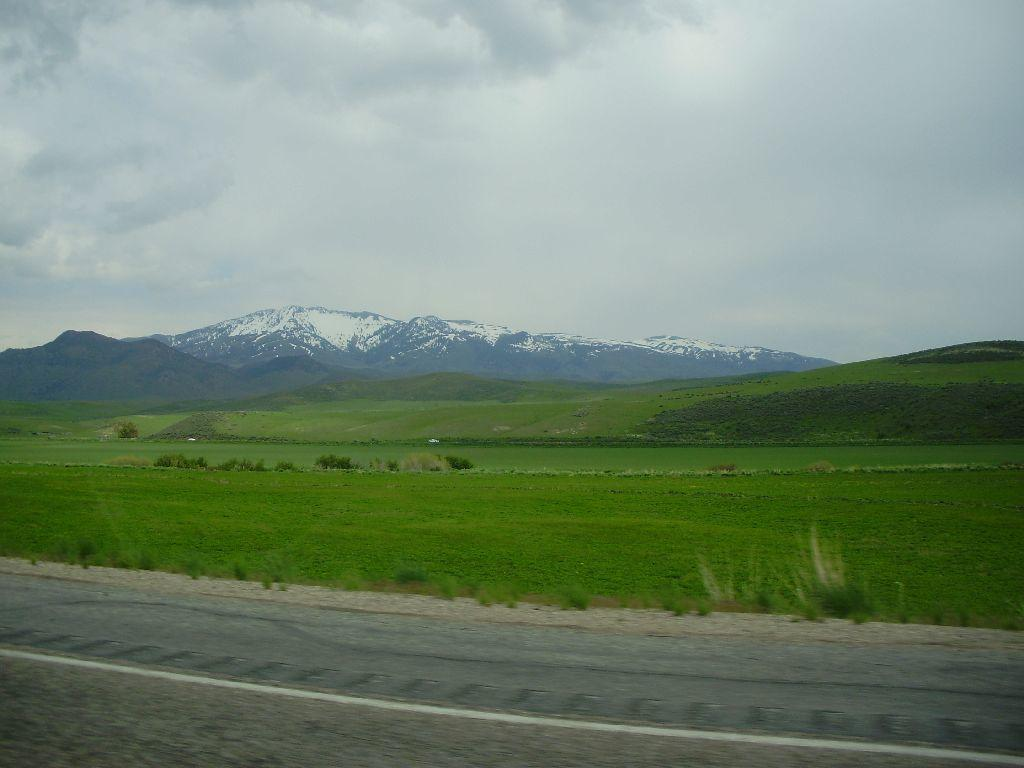What is the main feature of the image? There is a road in the image. What can be seen in the distance behind the road? In the background, there is a field and mountains. How would you describe the sky in the image? The sky is cloudy in the background. What invention is being demonstrated in the image? There is no invention being demonstrated in the image; it simply shows a road, a field, mountains, and a cloudy sky. Can you see the sea in the image? No, the sea is not visible in the image; it features a road, a field, mountains, and a cloudy sky. 